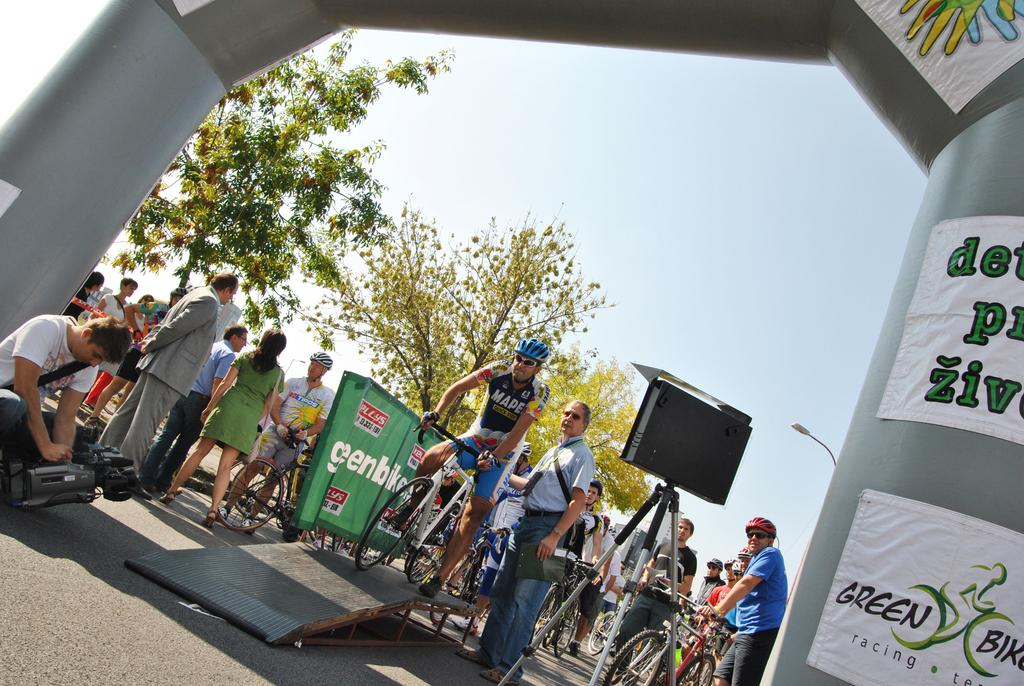What can be seen in the background of the image? There is a sky in the image. What type of vegetation is visible in the image? There are trees in the image. What is hanging or attached in the image? There is a banner in the image. What are the people in the image doing? The people in the image are standing and sitting. What mode of transportation can be seen in the image? There are bicycles in the image. What type of eggnog is being served at the event depicted in the image? There is no mention of eggnog or any event in the image; it simply shows a sky, trees, a banner, people, and bicycles. 